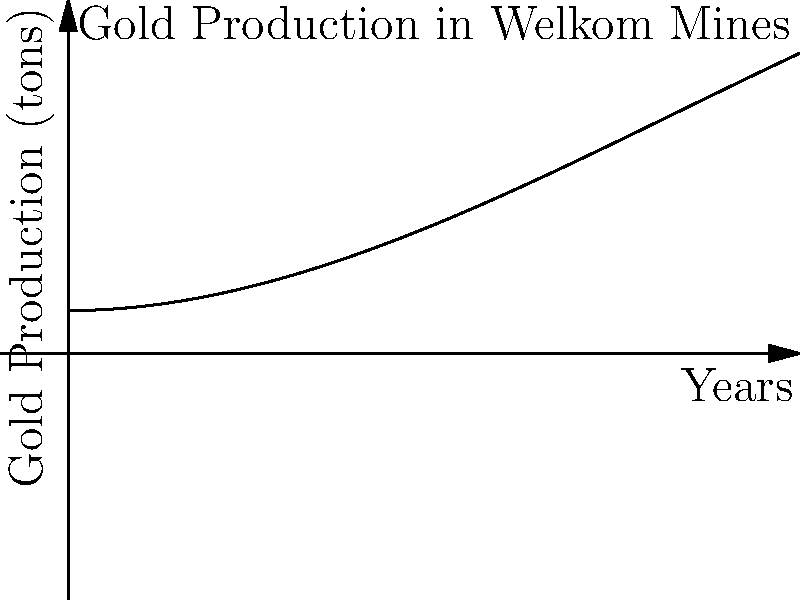The graph represents the gold production in Welkom's mines over a 10-year period. If the function describing the production is $f(x) = 5 + 0.5x^2 - 0.02x^3$, where $x$ is the number of years and $f(x)$ is the gold production in tons, calculate the total gold production over the entire period. To find the total gold production over the 10-year period, we need to calculate the area under the curve from x = 0 to x = 10. This can be done using definite integration.

Step 1: Set up the definite integral
$$\int_0^{10} (5 + 0.5x^2 - 0.02x^3) dx$$

Step 2: Integrate the function
$$\left[5x + \frac{1}{6}x^3 - \frac{0.02}{4}x^4\right]_0^{10}$$

Step 3: Evaluate the integral at the upper and lower bounds
Upper bound (x = 10):
$$5(10) + \frac{1}{6}(10^3) - \frac{0.02}{4}(10^4) = 50 + 166.67 - 50 = 166.67$$

Lower bound (x = 0):
$$5(0) + \frac{1}{6}(0^3) - \frac{0.02}{4}(0^4) = 0$$

Step 4: Subtract the lower bound result from the upper bound result
$$166.67 - 0 = 166.67$$

Therefore, the total gold production over the 10-year period is approximately 166.67 tons.
Answer: 166.67 tons 